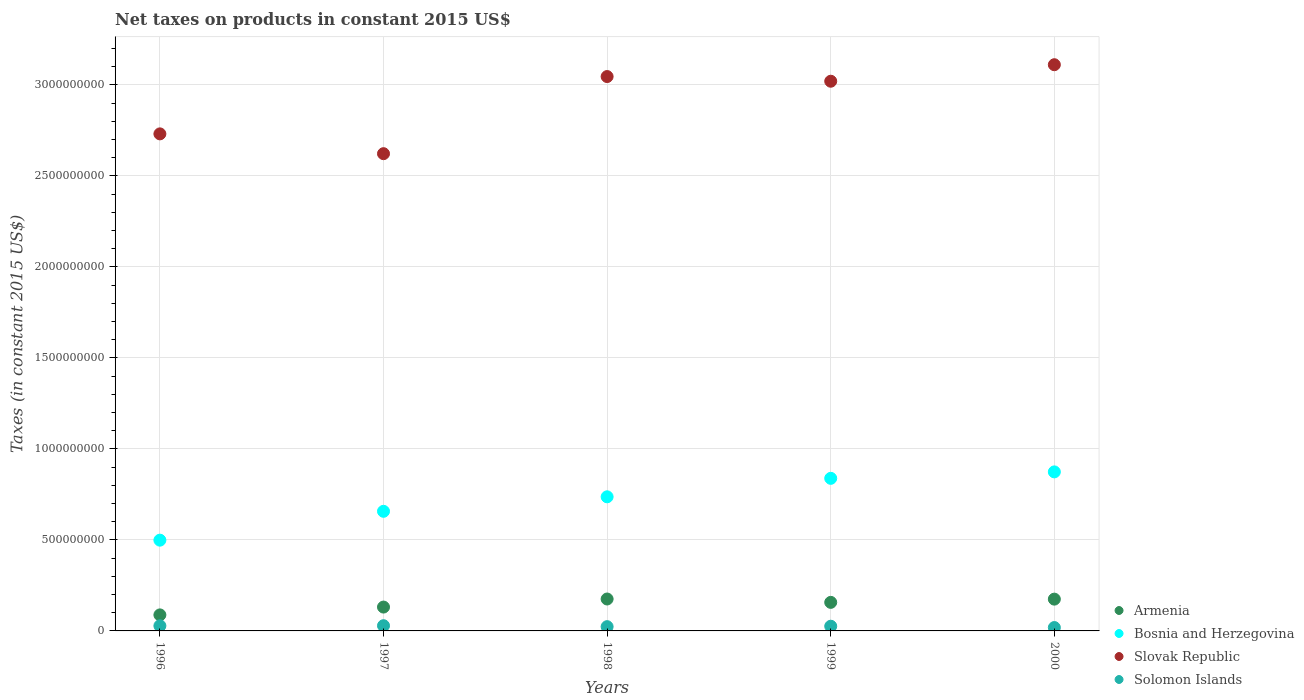How many different coloured dotlines are there?
Offer a very short reply. 4. Is the number of dotlines equal to the number of legend labels?
Provide a short and direct response. Yes. What is the net taxes on products in Slovak Republic in 1997?
Ensure brevity in your answer.  2.62e+09. Across all years, what is the maximum net taxes on products in Bosnia and Herzegovina?
Provide a succinct answer. 8.74e+08. Across all years, what is the minimum net taxes on products in Bosnia and Herzegovina?
Ensure brevity in your answer.  4.99e+08. What is the total net taxes on products in Solomon Islands in the graph?
Offer a very short reply. 1.25e+08. What is the difference between the net taxes on products in Solomon Islands in 1999 and that in 2000?
Your answer should be compact. 7.27e+06. What is the difference between the net taxes on products in Solomon Islands in 1999 and the net taxes on products in Slovak Republic in 1996?
Offer a terse response. -2.71e+09. What is the average net taxes on products in Solomon Islands per year?
Offer a very short reply. 2.49e+07. In the year 2000, what is the difference between the net taxes on products in Bosnia and Herzegovina and net taxes on products in Slovak Republic?
Offer a terse response. -2.24e+09. What is the ratio of the net taxes on products in Slovak Republic in 1997 to that in 1998?
Your answer should be compact. 0.86. Is the net taxes on products in Solomon Islands in 1998 less than that in 1999?
Make the answer very short. Yes. Is the difference between the net taxes on products in Bosnia and Herzegovina in 1997 and 2000 greater than the difference between the net taxes on products in Slovak Republic in 1997 and 2000?
Make the answer very short. Yes. What is the difference between the highest and the second highest net taxes on products in Solomon Islands?
Ensure brevity in your answer.  5.57e+05. What is the difference between the highest and the lowest net taxes on products in Bosnia and Herzegovina?
Offer a terse response. 3.75e+08. Is the sum of the net taxes on products in Solomon Islands in 1996 and 1997 greater than the maximum net taxes on products in Slovak Republic across all years?
Ensure brevity in your answer.  No. Does the net taxes on products in Bosnia and Herzegovina monotonically increase over the years?
Keep it short and to the point. Yes. Is the net taxes on products in Armenia strictly less than the net taxes on products in Solomon Islands over the years?
Your response must be concise. No. How many dotlines are there?
Your response must be concise. 4. How many years are there in the graph?
Your answer should be very brief. 5. What is the difference between two consecutive major ticks on the Y-axis?
Provide a short and direct response. 5.00e+08. Are the values on the major ticks of Y-axis written in scientific E-notation?
Provide a succinct answer. No. Does the graph contain any zero values?
Give a very brief answer. No. What is the title of the graph?
Your answer should be compact. Net taxes on products in constant 2015 US$. What is the label or title of the Y-axis?
Offer a terse response. Taxes (in constant 2015 US$). What is the Taxes (in constant 2015 US$) in Armenia in 1996?
Provide a succinct answer. 8.81e+07. What is the Taxes (in constant 2015 US$) in Bosnia and Herzegovina in 1996?
Offer a terse response. 4.99e+08. What is the Taxes (in constant 2015 US$) of Slovak Republic in 1996?
Give a very brief answer. 2.73e+09. What is the Taxes (in constant 2015 US$) of Solomon Islands in 1996?
Ensure brevity in your answer.  2.81e+07. What is the Taxes (in constant 2015 US$) in Armenia in 1997?
Ensure brevity in your answer.  1.31e+08. What is the Taxes (in constant 2015 US$) in Bosnia and Herzegovina in 1997?
Ensure brevity in your answer.  6.57e+08. What is the Taxes (in constant 2015 US$) of Slovak Republic in 1997?
Your answer should be very brief. 2.62e+09. What is the Taxes (in constant 2015 US$) in Solomon Islands in 1997?
Offer a terse response. 2.87e+07. What is the Taxes (in constant 2015 US$) of Armenia in 1998?
Ensure brevity in your answer.  1.75e+08. What is the Taxes (in constant 2015 US$) in Bosnia and Herzegovina in 1998?
Your answer should be compact. 7.37e+08. What is the Taxes (in constant 2015 US$) in Slovak Republic in 1998?
Give a very brief answer. 3.05e+09. What is the Taxes (in constant 2015 US$) of Solomon Islands in 1998?
Offer a terse response. 2.34e+07. What is the Taxes (in constant 2015 US$) in Armenia in 1999?
Make the answer very short. 1.57e+08. What is the Taxes (in constant 2015 US$) of Bosnia and Herzegovina in 1999?
Give a very brief answer. 8.38e+08. What is the Taxes (in constant 2015 US$) in Slovak Republic in 1999?
Keep it short and to the point. 3.02e+09. What is the Taxes (in constant 2015 US$) in Solomon Islands in 1999?
Give a very brief answer. 2.58e+07. What is the Taxes (in constant 2015 US$) of Armenia in 2000?
Provide a succinct answer. 1.75e+08. What is the Taxes (in constant 2015 US$) in Bosnia and Herzegovina in 2000?
Your answer should be compact. 8.74e+08. What is the Taxes (in constant 2015 US$) of Slovak Republic in 2000?
Offer a very short reply. 3.11e+09. What is the Taxes (in constant 2015 US$) of Solomon Islands in 2000?
Give a very brief answer. 1.86e+07. Across all years, what is the maximum Taxes (in constant 2015 US$) of Armenia?
Ensure brevity in your answer.  1.75e+08. Across all years, what is the maximum Taxes (in constant 2015 US$) in Bosnia and Herzegovina?
Provide a succinct answer. 8.74e+08. Across all years, what is the maximum Taxes (in constant 2015 US$) in Slovak Republic?
Your response must be concise. 3.11e+09. Across all years, what is the maximum Taxes (in constant 2015 US$) of Solomon Islands?
Offer a very short reply. 2.87e+07. Across all years, what is the minimum Taxes (in constant 2015 US$) of Armenia?
Provide a succinct answer. 8.81e+07. Across all years, what is the minimum Taxes (in constant 2015 US$) of Bosnia and Herzegovina?
Make the answer very short. 4.99e+08. Across all years, what is the minimum Taxes (in constant 2015 US$) of Slovak Republic?
Your answer should be compact. 2.62e+09. Across all years, what is the minimum Taxes (in constant 2015 US$) of Solomon Islands?
Keep it short and to the point. 1.86e+07. What is the total Taxes (in constant 2015 US$) of Armenia in the graph?
Your answer should be compact. 7.26e+08. What is the total Taxes (in constant 2015 US$) in Bosnia and Herzegovina in the graph?
Make the answer very short. 3.61e+09. What is the total Taxes (in constant 2015 US$) of Slovak Republic in the graph?
Give a very brief answer. 1.45e+1. What is the total Taxes (in constant 2015 US$) in Solomon Islands in the graph?
Provide a succinct answer. 1.25e+08. What is the difference between the Taxes (in constant 2015 US$) in Armenia in 1996 and that in 1997?
Give a very brief answer. -4.30e+07. What is the difference between the Taxes (in constant 2015 US$) in Bosnia and Herzegovina in 1996 and that in 1997?
Offer a very short reply. -1.59e+08. What is the difference between the Taxes (in constant 2015 US$) of Slovak Republic in 1996 and that in 1997?
Provide a succinct answer. 1.09e+08. What is the difference between the Taxes (in constant 2015 US$) of Solomon Islands in 1996 and that in 1997?
Your response must be concise. -5.57e+05. What is the difference between the Taxes (in constant 2015 US$) of Armenia in 1996 and that in 1998?
Your answer should be compact. -8.73e+07. What is the difference between the Taxes (in constant 2015 US$) of Bosnia and Herzegovina in 1996 and that in 1998?
Ensure brevity in your answer.  -2.38e+08. What is the difference between the Taxes (in constant 2015 US$) in Slovak Republic in 1996 and that in 1998?
Give a very brief answer. -3.15e+08. What is the difference between the Taxes (in constant 2015 US$) in Solomon Islands in 1996 and that in 1998?
Give a very brief answer. 4.67e+06. What is the difference between the Taxes (in constant 2015 US$) of Armenia in 1996 and that in 1999?
Provide a short and direct response. -6.88e+07. What is the difference between the Taxes (in constant 2015 US$) of Bosnia and Herzegovina in 1996 and that in 1999?
Offer a very short reply. -3.40e+08. What is the difference between the Taxes (in constant 2015 US$) in Slovak Republic in 1996 and that in 1999?
Your response must be concise. -2.89e+08. What is the difference between the Taxes (in constant 2015 US$) in Solomon Islands in 1996 and that in 1999?
Offer a terse response. 2.28e+06. What is the difference between the Taxes (in constant 2015 US$) in Armenia in 1996 and that in 2000?
Provide a succinct answer. -8.66e+07. What is the difference between the Taxes (in constant 2015 US$) in Bosnia and Herzegovina in 1996 and that in 2000?
Ensure brevity in your answer.  -3.75e+08. What is the difference between the Taxes (in constant 2015 US$) of Slovak Republic in 1996 and that in 2000?
Your response must be concise. -3.80e+08. What is the difference between the Taxes (in constant 2015 US$) of Solomon Islands in 1996 and that in 2000?
Your response must be concise. 9.55e+06. What is the difference between the Taxes (in constant 2015 US$) in Armenia in 1997 and that in 1998?
Offer a very short reply. -4.43e+07. What is the difference between the Taxes (in constant 2015 US$) of Bosnia and Herzegovina in 1997 and that in 1998?
Offer a terse response. -7.96e+07. What is the difference between the Taxes (in constant 2015 US$) of Slovak Republic in 1997 and that in 1998?
Make the answer very short. -4.24e+08. What is the difference between the Taxes (in constant 2015 US$) in Solomon Islands in 1997 and that in 1998?
Make the answer very short. 5.23e+06. What is the difference between the Taxes (in constant 2015 US$) of Armenia in 1997 and that in 1999?
Provide a succinct answer. -2.58e+07. What is the difference between the Taxes (in constant 2015 US$) in Bosnia and Herzegovina in 1997 and that in 1999?
Offer a very short reply. -1.81e+08. What is the difference between the Taxes (in constant 2015 US$) of Slovak Republic in 1997 and that in 1999?
Your answer should be very brief. -3.98e+08. What is the difference between the Taxes (in constant 2015 US$) of Solomon Islands in 1997 and that in 1999?
Ensure brevity in your answer.  2.84e+06. What is the difference between the Taxes (in constant 2015 US$) of Armenia in 1997 and that in 2000?
Make the answer very short. -4.36e+07. What is the difference between the Taxes (in constant 2015 US$) in Bosnia and Herzegovina in 1997 and that in 2000?
Make the answer very short. -2.17e+08. What is the difference between the Taxes (in constant 2015 US$) of Slovak Republic in 1997 and that in 2000?
Give a very brief answer. -4.89e+08. What is the difference between the Taxes (in constant 2015 US$) of Solomon Islands in 1997 and that in 2000?
Make the answer very short. 1.01e+07. What is the difference between the Taxes (in constant 2015 US$) in Armenia in 1998 and that in 1999?
Your response must be concise. 1.85e+07. What is the difference between the Taxes (in constant 2015 US$) in Bosnia and Herzegovina in 1998 and that in 1999?
Provide a succinct answer. -1.02e+08. What is the difference between the Taxes (in constant 2015 US$) in Slovak Republic in 1998 and that in 1999?
Offer a terse response. 2.57e+07. What is the difference between the Taxes (in constant 2015 US$) of Solomon Islands in 1998 and that in 1999?
Make the answer very short. -2.39e+06. What is the difference between the Taxes (in constant 2015 US$) in Armenia in 1998 and that in 2000?
Your answer should be compact. 7.20e+05. What is the difference between the Taxes (in constant 2015 US$) of Bosnia and Herzegovina in 1998 and that in 2000?
Offer a terse response. -1.37e+08. What is the difference between the Taxes (in constant 2015 US$) in Slovak Republic in 1998 and that in 2000?
Offer a terse response. -6.50e+07. What is the difference between the Taxes (in constant 2015 US$) in Solomon Islands in 1998 and that in 2000?
Your answer should be compact. 4.87e+06. What is the difference between the Taxes (in constant 2015 US$) in Armenia in 1999 and that in 2000?
Your response must be concise. -1.78e+07. What is the difference between the Taxes (in constant 2015 US$) in Bosnia and Herzegovina in 1999 and that in 2000?
Keep it short and to the point. -3.54e+07. What is the difference between the Taxes (in constant 2015 US$) in Slovak Republic in 1999 and that in 2000?
Offer a terse response. -9.08e+07. What is the difference between the Taxes (in constant 2015 US$) of Solomon Islands in 1999 and that in 2000?
Ensure brevity in your answer.  7.27e+06. What is the difference between the Taxes (in constant 2015 US$) in Armenia in 1996 and the Taxes (in constant 2015 US$) in Bosnia and Herzegovina in 1997?
Keep it short and to the point. -5.69e+08. What is the difference between the Taxes (in constant 2015 US$) in Armenia in 1996 and the Taxes (in constant 2015 US$) in Slovak Republic in 1997?
Ensure brevity in your answer.  -2.53e+09. What is the difference between the Taxes (in constant 2015 US$) of Armenia in 1996 and the Taxes (in constant 2015 US$) of Solomon Islands in 1997?
Offer a very short reply. 5.94e+07. What is the difference between the Taxes (in constant 2015 US$) in Bosnia and Herzegovina in 1996 and the Taxes (in constant 2015 US$) in Slovak Republic in 1997?
Offer a terse response. -2.12e+09. What is the difference between the Taxes (in constant 2015 US$) of Bosnia and Herzegovina in 1996 and the Taxes (in constant 2015 US$) of Solomon Islands in 1997?
Make the answer very short. 4.70e+08. What is the difference between the Taxes (in constant 2015 US$) of Slovak Republic in 1996 and the Taxes (in constant 2015 US$) of Solomon Islands in 1997?
Your answer should be very brief. 2.70e+09. What is the difference between the Taxes (in constant 2015 US$) of Armenia in 1996 and the Taxes (in constant 2015 US$) of Bosnia and Herzegovina in 1998?
Keep it short and to the point. -6.49e+08. What is the difference between the Taxes (in constant 2015 US$) of Armenia in 1996 and the Taxes (in constant 2015 US$) of Slovak Republic in 1998?
Your answer should be very brief. -2.96e+09. What is the difference between the Taxes (in constant 2015 US$) in Armenia in 1996 and the Taxes (in constant 2015 US$) in Solomon Islands in 1998?
Give a very brief answer. 6.46e+07. What is the difference between the Taxes (in constant 2015 US$) in Bosnia and Herzegovina in 1996 and the Taxes (in constant 2015 US$) in Slovak Republic in 1998?
Ensure brevity in your answer.  -2.55e+09. What is the difference between the Taxes (in constant 2015 US$) in Bosnia and Herzegovina in 1996 and the Taxes (in constant 2015 US$) in Solomon Islands in 1998?
Give a very brief answer. 4.75e+08. What is the difference between the Taxes (in constant 2015 US$) in Slovak Republic in 1996 and the Taxes (in constant 2015 US$) in Solomon Islands in 1998?
Offer a terse response. 2.71e+09. What is the difference between the Taxes (in constant 2015 US$) in Armenia in 1996 and the Taxes (in constant 2015 US$) in Bosnia and Herzegovina in 1999?
Offer a terse response. -7.50e+08. What is the difference between the Taxes (in constant 2015 US$) in Armenia in 1996 and the Taxes (in constant 2015 US$) in Slovak Republic in 1999?
Make the answer very short. -2.93e+09. What is the difference between the Taxes (in constant 2015 US$) in Armenia in 1996 and the Taxes (in constant 2015 US$) in Solomon Islands in 1999?
Give a very brief answer. 6.23e+07. What is the difference between the Taxes (in constant 2015 US$) in Bosnia and Herzegovina in 1996 and the Taxes (in constant 2015 US$) in Slovak Republic in 1999?
Make the answer very short. -2.52e+09. What is the difference between the Taxes (in constant 2015 US$) of Bosnia and Herzegovina in 1996 and the Taxes (in constant 2015 US$) of Solomon Islands in 1999?
Provide a short and direct response. 4.73e+08. What is the difference between the Taxes (in constant 2015 US$) of Slovak Republic in 1996 and the Taxes (in constant 2015 US$) of Solomon Islands in 1999?
Your answer should be very brief. 2.71e+09. What is the difference between the Taxes (in constant 2015 US$) of Armenia in 1996 and the Taxes (in constant 2015 US$) of Bosnia and Herzegovina in 2000?
Offer a terse response. -7.86e+08. What is the difference between the Taxes (in constant 2015 US$) in Armenia in 1996 and the Taxes (in constant 2015 US$) in Slovak Republic in 2000?
Your answer should be compact. -3.02e+09. What is the difference between the Taxes (in constant 2015 US$) in Armenia in 1996 and the Taxes (in constant 2015 US$) in Solomon Islands in 2000?
Provide a short and direct response. 6.95e+07. What is the difference between the Taxes (in constant 2015 US$) in Bosnia and Herzegovina in 1996 and the Taxes (in constant 2015 US$) in Slovak Republic in 2000?
Your answer should be compact. -2.61e+09. What is the difference between the Taxes (in constant 2015 US$) of Bosnia and Herzegovina in 1996 and the Taxes (in constant 2015 US$) of Solomon Islands in 2000?
Your response must be concise. 4.80e+08. What is the difference between the Taxes (in constant 2015 US$) of Slovak Republic in 1996 and the Taxes (in constant 2015 US$) of Solomon Islands in 2000?
Ensure brevity in your answer.  2.71e+09. What is the difference between the Taxes (in constant 2015 US$) of Armenia in 1997 and the Taxes (in constant 2015 US$) of Bosnia and Herzegovina in 1998?
Provide a succinct answer. -6.06e+08. What is the difference between the Taxes (in constant 2015 US$) of Armenia in 1997 and the Taxes (in constant 2015 US$) of Slovak Republic in 1998?
Your answer should be compact. -2.91e+09. What is the difference between the Taxes (in constant 2015 US$) in Armenia in 1997 and the Taxes (in constant 2015 US$) in Solomon Islands in 1998?
Your response must be concise. 1.08e+08. What is the difference between the Taxes (in constant 2015 US$) in Bosnia and Herzegovina in 1997 and the Taxes (in constant 2015 US$) in Slovak Republic in 1998?
Your response must be concise. -2.39e+09. What is the difference between the Taxes (in constant 2015 US$) of Bosnia and Herzegovina in 1997 and the Taxes (in constant 2015 US$) of Solomon Islands in 1998?
Your response must be concise. 6.34e+08. What is the difference between the Taxes (in constant 2015 US$) of Slovak Republic in 1997 and the Taxes (in constant 2015 US$) of Solomon Islands in 1998?
Ensure brevity in your answer.  2.60e+09. What is the difference between the Taxes (in constant 2015 US$) in Armenia in 1997 and the Taxes (in constant 2015 US$) in Bosnia and Herzegovina in 1999?
Make the answer very short. -7.07e+08. What is the difference between the Taxes (in constant 2015 US$) in Armenia in 1997 and the Taxes (in constant 2015 US$) in Slovak Republic in 1999?
Provide a succinct answer. -2.89e+09. What is the difference between the Taxes (in constant 2015 US$) of Armenia in 1997 and the Taxes (in constant 2015 US$) of Solomon Islands in 1999?
Provide a succinct answer. 1.05e+08. What is the difference between the Taxes (in constant 2015 US$) of Bosnia and Herzegovina in 1997 and the Taxes (in constant 2015 US$) of Slovak Republic in 1999?
Give a very brief answer. -2.36e+09. What is the difference between the Taxes (in constant 2015 US$) in Bosnia and Herzegovina in 1997 and the Taxes (in constant 2015 US$) in Solomon Islands in 1999?
Offer a terse response. 6.31e+08. What is the difference between the Taxes (in constant 2015 US$) in Slovak Republic in 1997 and the Taxes (in constant 2015 US$) in Solomon Islands in 1999?
Provide a succinct answer. 2.60e+09. What is the difference between the Taxes (in constant 2015 US$) of Armenia in 1997 and the Taxes (in constant 2015 US$) of Bosnia and Herzegovina in 2000?
Your answer should be compact. -7.43e+08. What is the difference between the Taxes (in constant 2015 US$) in Armenia in 1997 and the Taxes (in constant 2015 US$) in Slovak Republic in 2000?
Your answer should be very brief. -2.98e+09. What is the difference between the Taxes (in constant 2015 US$) in Armenia in 1997 and the Taxes (in constant 2015 US$) in Solomon Islands in 2000?
Offer a terse response. 1.13e+08. What is the difference between the Taxes (in constant 2015 US$) in Bosnia and Herzegovina in 1997 and the Taxes (in constant 2015 US$) in Slovak Republic in 2000?
Your answer should be compact. -2.45e+09. What is the difference between the Taxes (in constant 2015 US$) of Bosnia and Herzegovina in 1997 and the Taxes (in constant 2015 US$) of Solomon Islands in 2000?
Your answer should be very brief. 6.39e+08. What is the difference between the Taxes (in constant 2015 US$) of Slovak Republic in 1997 and the Taxes (in constant 2015 US$) of Solomon Islands in 2000?
Provide a succinct answer. 2.60e+09. What is the difference between the Taxes (in constant 2015 US$) of Armenia in 1998 and the Taxes (in constant 2015 US$) of Bosnia and Herzegovina in 1999?
Your response must be concise. -6.63e+08. What is the difference between the Taxes (in constant 2015 US$) in Armenia in 1998 and the Taxes (in constant 2015 US$) in Slovak Republic in 1999?
Provide a short and direct response. -2.84e+09. What is the difference between the Taxes (in constant 2015 US$) of Armenia in 1998 and the Taxes (in constant 2015 US$) of Solomon Islands in 1999?
Your response must be concise. 1.50e+08. What is the difference between the Taxes (in constant 2015 US$) in Bosnia and Herzegovina in 1998 and the Taxes (in constant 2015 US$) in Slovak Republic in 1999?
Your answer should be compact. -2.28e+09. What is the difference between the Taxes (in constant 2015 US$) of Bosnia and Herzegovina in 1998 and the Taxes (in constant 2015 US$) of Solomon Islands in 1999?
Keep it short and to the point. 7.11e+08. What is the difference between the Taxes (in constant 2015 US$) in Slovak Republic in 1998 and the Taxes (in constant 2015 US$) in Solomon Islands in 1999?
Your answer should be compact. 3.02e+09. What is the difference between the Taxes (in constant 2015 US$) of Armenia in 1998 and the Taxes (in constant 2015 US$) of Bosnia and Herzegovina in 2000?
Give a very brief answer. -6.98e+08. What is the difference between the Taxes (in constant 2015 US$) in Armenia in 1998 and the Taxes (in constant 2015 US$) in Slovak Republic in 2000?
Offer a terse response. -2.94e+09. What is the difference between the Taxes (in constant 2015 US$) in Armenia in 1998 and the Taxes (in constant 2015 US$) in Solomon Islands in 2000?
Your answer should be compact. 1.57e+08. What is the difference between the Taxes (in constant 2015 US$) in Bosnia and Herzegovina in 1998 and the Taxes (in constant 2015 US$) in Slovak Republic in 2000?
Make the answer very short. -2.37e+09. What is the difference between the Taxes (in constant 2015 US$) in Bosnia and Herzegovina in 1998 and the Taxes (in constant 2015 US$) in Solomon Islands in 2000?
Your response must be concise. 7.18e+08. What is the difference between the Taxes (in constant 2015 US$) in Slovak Republic in 1998 and the Taxes (in constant 2015 US$) in Solomon Islands in 2000?
Provide a succinct answer. 3.03e+09. What is the difference between the Taxes (in constant 2015 US$) of Armenia in 1999 and the Taxes (in constant 2015 US$) of Bosnia and Herzegovina in 2000?
Provide a succinct answer. -7.17e+08. What is the difference between the Taxes (in constant 2015 US$) in Armenia in 1999 and the Taxes (in constant 2015 US$) in Slovak Republic in 2000?
Your answer should be compact. -2.95e+09. What is the difference between the Taxes (in constant 2015 US$) in Armenia in 1999 and the Taxes (in constant 2015 US$) in Solomon Islands in 2000?
Your answer should be very brief. 1.38e+08. What is the difference between the Taxes (in constant 2015 US$) of Bosnia and Herzegovina in 1999 and the Taxes (in constant 2015 US$) of Slovak Republic in 2000?
Your answer should be compact. -2.27e+09. What is the difference between the Taxes (in constant 2015 US$) of Bosnia and Herzegovina in 1999 and the Taxes (in constant 2015 US$) of Solomon Islands in 2000?
Offer a terse response. 8.20e+08. What is the difference between the Taxes (in constant 2015 US$) in Slovak Republic in 1999 and the Taxes (in constant 2015 US$) in Solomon Islands in 2000?
Offer a very short reply. 3.00e+09. What is the average Taxes (in constant 2015 US$) in Armenia per year?
Ensure brevity in your answer.  1.45e+08. What is the average Taxes (in constant 2015 US$) of Bosnia and Herzegovina per year?
Your response must be concise. 7.21e+08. What is the average Taxes (in constant 2015 US$) in Slovak Republic per year?
Keep it short and to the point. 2.91e+09. What is the average Taxes (in constant 2015 US$) of Solomon Islands per year?
Make the answer very short. 2.49e+07. In the year 1996, what is the difference between the Taxes (in constant 2015 US$) in Armenia and Taxes (in constant 2015 US$) in Bosnia and Herzegovina?
Provide a succinct answer. -4.11e+08. In the year 1996, what is the difference between the Taxes (in constant 2015 US$) of Armenia and Taxes (in constant 2015 US$) of Slovak Republic?
Your answer should be very brief. -2.64e+09. In the year 1996, what is the difference between the Taxes (in constant 2015 US$) of Armenia and Taxes (in constant 2015 US$) of Solomon Islands?
Offer a terse response. 6.00e+07. In the year 1996, what is the difference between the Taxes (in constant 2015 US$) of Bosnia and Herzegovina and Taxes (in constant 2015 US$) of Slovak Republic?
Offer a terse response. -2.23e+09. In the year 1996, what is the difference between the Taxes (in constant 2015 US$) in Bosnia and Herzegovina and Taxes (in constant 2015 US$) in Solomon Islands?
Ensure brevity in your answer.  4.71e+08. In the year 1996, what is the difference between the Taxes (in constant 2015 US$) of Slovak Republic and Taxes (in constant 2015 US$) of Solomon Islands?
Offer a terse response. 2.70e+09. In the year 1997, what is the difference between the Taxes (in constant 2015 US$) of Armenia and Taxes (in constant 2015 US$) of Bosnia and Herzegovina?
Give a very brief answer. -5.26e+08. In the year 1997, what is the difference between the Taxes (in constant 2015 US$) in Armenia and Taxes (in constant 2015 US$) in Slovak Republic?
Your answer should be compact. -2.49e+09. In the year 1997, what is the difference between the Taxes (in constant 2015 US$) in Armenia and Taxes (in constant 2015 US$) in Solomon Islands?
Give a very brief answer. 1.02e+08. In the year 1997, what is the difference between the Taxes (in constant 2015 US$) in Bosnia and Herzegovina and Taxes (in constant 2015 US$) in Slovak Republic?
Your answer should be very brief. -1.97e+09. In the year 1997, what is the difference between the Taxes (in constant 2015 US$) in Bosnia and Herzegovina and Taxes (in constant 2015 US$) in Solomon Islands?
Your answer should be compact. 6.29e+08. In the year 1997, what is the difference between the Taxes (in constant 2015 US$) of Slovak Republic and Taxes (in constant 2015 US$) of Solomon Islands?
Your answer should be very brief. 2.59e+09. In the year 1998, what is the difference between the Taxes (in constant 2015 US$) in Armenia and Taxes (in constant 2015 US$) in Bosnia and Herzegovina?
Your answer should be compact. -5.62e+08. In the year 1998, what is the difference between the Taxes (in constant 2015 US$) in Armenia and Taxes (in constant 2015 US$) in Slovak Republic?
Ensure brevity in your answer.  -2.87e+09. In the year 1998, what is the difference between the Taxes (in constant 2015 US$) in Armenia and Taxes (in constant 2015 US$) in Solomon Islands?
Your answer should be compact. 1.52e+08. In the year 1998, what is the difference between the Taxes (in constant 2015 US$) in Bosnia and Herzegovina and Taxes (in constant 2015 US$) in Slovak Republic?
Provide a short and direct response. -2.31e+09. In the year 1998, what is the difference between the Taxes (in constant 2015 US$) of Bosnia and Herzegovina and Taxes (in constant 2015 US$) of Solomon Islands?
Keep it short and to the point. 7.13e+08. In the year 1998, what is the difference between the Taxes (in constant 2015 US$) in Slovak Republic and Taxes (in constant 2015 US$) in Solomon Islands?
Make the answer very short. 3.02e+09. In the year 1999, what is the difference between the Taxes (in constant 2015 US$) in Armenia and Taxes (in constant 2015 US$) in Bosnia and Herzegovina?
Keep it short and to the point. -6.82e+08. In the year 1999, what is the difference between the Taxes (in constant 2015 US$) of Armenia and Taxes (in constant 2015 US$) of Slovak Republic?
Provide a short and direct response. -2.86e+09. In the year 1999, what is the difference between the Taxes (in constant 2015 US$) in Armenia and Taxes (in constant 2015 US$) in Solomon Islands?
Give a very brief answer. 1.31e+08. In the year 1999, what is the difference between the Taxes (in constant 2015 US$) of Bosnia and Herzegovina and Taxes (in constant 2015 US$) of Slovak Republic?
Give a very brief answer. -2.18e+09. In the year 1999, what is the difference between the Taxes (in constant 2015 US$) in Bosnia and Herzegovina and Taxes (in constant 2015 US$) in Solomon Islands?
Offer a terse response. 8.13e+08. In the year 1999, what is the difference between the Taxes (in constant 2015 US$) of Slovak Republic and Taxes (in constant 2015 US$) of Solomon Islands?
Offer a terse response. 2.99e+09. In the year 2000, what is the difference between the Taxes (in constant 2015 US$) of Armenia and Taxes (in constant 2015 US$) of Bosnia and Herzegovina?
Make the answer very short. -6.99e+08. In the year 2000, what is the difference between the Taxes (in constant 2015 US$) of Armenia and Taxes (in constant 2015 US$) of Slovak Republic?
Your response must be concise. -2.94e+09. In the year 2000, what is the difference between the Taxes (in constant 2015 US$) of Armenia and Taxes (in constant 2015 US$) of Solomon Islands?
Ensure brevity in your answer.  1.56e+08. In the year 2000, what is the difference between the Taxes (in constant 2015 US$) in Bosnia and Herzegovina and Taxes (in constant 2015 US$) in Slovak Republic?
Ensure brevity in your answer.  -2.24e+09. In the year 2000, what is the difference between the Taxes (in constant 2015 US$) of Bosnia and Herzegovina and Taxes (in constant 2015 US$) of Solomon Islands?
Make the answer very short. 8.55e+08. In the year 2000, what is the difference between the Taxes (in constant 2015 US$) of Slovak Republic and Taxes (in constant 2015 US$) of Solomon Islands?
Give a very brief answer. 3.09e+09. What is the ratio of the Taxes (in constant 2015 US$) of Armenia in 1996 to that in 1997?
Provide a short and direct response. 0.67. What is the ratio of the Taxes (in constant 2015 US$) in Bosnia and Herzegovina in 1996 to that in 1997?
Your answer should be compact. 0.76. What is the ratio of the Taxes (in constant 2015 US$) of Slovak Republic in 1996 to that in 1997?
Your answer should be compact. 1.04. What is the ratio of the Taxes (in constant 2015 US$) in Solomon Islands in 1996 to that in 1997?
Offer a terse response. 0.98. What is the ratio of the Taxes (in constant 2015 US$) in Armenia in 1996 to that in 1998?
Your response must be concise. 0.5. What is the ratio of the Taxes (in constant 2015 US$) in Bosnia and Herzegovina in 1996 to that in 1998?
Offer a very short reply. 0.68. What is the ratio of the Taxes (in constant 2015 US$) in Slovak Republic in 1996 to that in 1998?
Give a very brief answer. 0.9. What is the ratio of the Taxes (in constant 2015 US$) of Solomon Islands in 1996 to that in 1998?
Your answer should be very brief. 1.2. What is the ratio of the Taxes (in constant 2015 US$) in Armenia in 1996 to that in 1999?
Your answer should be very brief. 0.56. What is the ratio of the Taxes (in constant 2015 US$) in Bosnia and Herzegovina in 1996 to that in 1999?
Give a very brief answer. 0.59. What is the ratio of the Taxes (in constant 2015 US$) of Slovak Republic in 1996 to that in 1999?
Provide a short and direct response. 0.9. What is the ratio of the Taxes (in constant 2015 US$) in Solomon Islands in 1996 to that in 1999?
Give a very brief answer. 1.09. What is the ratio of the Taxes (in constant 2015 US$) of Armenia in 1996 to that in 2000?
Keep it short and to the point. 0.5. What is the ratio of the Taxes (in constant 2015 US$) of Bosnia and Herzegovina in 1996 to that in 2000?
Ensure brevity in your answer.  0.57. What is the ratio of the Taxes (in constant 2015 US$) of Slovak Republic in 1996 to that in 2000?
Your answer should be compact. 0.88. What is the ratio of the Taxes (in constant 2015 US$) in Solomon Islands in 1996 to that in 2000?
Offer a terse response. 1.51. What is the ratio of the Taxes (in constant 2015 US$) in Armenia in 1997 to that in 1998?
Provide a succinct answer. 0.75. What is the ratio of the Taxes (in constant 2015 US$) of Bosnia and Herzegovina in 1997 to that in 1998?
Keep it short and to the point. 0.89. What is the ratio of the Taxes (in constant 2015 US$) in Slovak Republic in 1997 to that in 1998?
Your response must be concise. 0.86. What is the ratio of the Taxes (in constant 2015 US$) in Solomon Islands in 1997 to that in 1998?
Provide a succinct answer. 1.22. What is the ratio of the Taxes (in constant 2015 US$) in Armenia in 1997 to that in 1999?
Provide a succinct answer. 0.84. What is the ratio of the Taxes (in constant 2015 US$) in Bosnia and Herzegovina in 1997 to that in 1999?
Ensure brevity in your answer.  0.78. What is the ratio of the Taxes (in constant 2015 US$) in Slovak Republic in 1997 to that in 1999?
Ensure brevity in your answer.  0.87. What is the ratio of the Taxes (in constant 2015 US$) in Solomon Islands in 1997 to that in 1999?
Provide a succinct answer. 1.11. What is the ratio of the Taxes (in constant 2015 US$) of Armenia in 1997 to that in 2000?
Your response must be concise. 0.75. What is the ratio of the Taxes (in constant 2015 US$) of Bosnia and Herzegovina in 1997 to that in 2000?
Provide a succinct answer. 0.75. What is the ratio of the Taxes (in constant 2015 US$) of Slovak Republic in 1997 to that in 2000?
Offer a terse response. 0.84. What is the ratio of the Taxes (in constant 2015 US$) of Solomon Islands in 1997 to that in 2000?
Give a very brief answer. 1.54. What is the ratio of the Taxes (in constant 2015 US$) of Armenia in 1998 to that in 1999?
Ensure brevity in your answer.  1.12. What is the ratio of the Taxes (in constant 2015 US$) of Bosnia and Herzegovina in 1998 to that in 1999?
Provide a short and direct response. 0.88. What is the ratio of the Taxes (in constant 2015 US$) in Slovak Republic in 1998 to that in 1999?
Make the answer very short. 1.01. What is the ratio of the Taxes (in constant 2015 US$) in Solomon Islands in 1998 to that in 1999?
Ensure brevity in your answer.  0.91. What is the ratio of the Taxes (in constant 2015 US$) of Armenia in 1998 to that in 2000?
Make the answer very short. 1. What is the ratio of the Taxes (in constant 2015 US$) of Bosnia and Herzegovina in 1998 to that in 2000?
Provide a short and direct response. 0.84. What is the ratio of the Taxes (in constant 2015 US$) in Slovak Republic in 1998 to that in 2000?
Provide a succinct answer. 0.98. What is the ratio of the Taxes (in constant 2015 US$) in Solomon Islands in 1998 to that in 2000?
Your response must be concise. 1.26. What is the ratio of the Taxes (in constant 2015 US$) in Armenia in 1999 to that in 2000?
Keep it short and to the point. 0.9. What is the ratio of the Taxes (in constant 2015 US$) of Bosnia and Herzegovina in 1999 to that in 2000?
Provide a short and direct response. 0.96. What is the ratio of the Taxes (in constant 2015 US$) in Slovak Republic in 1999 to that in 2000?
Your answer should be compact. 0.97. What is the ratio of the Taxes (in constant 2015 US$) of Solomon Islands in 1999 to that in 2000?
Offer a very short reply. 1.39. What is the difference between the highest and the second highest Taxes (in constant 2015 US$) of Armenia?
Provide a short and direct response. 7.20e+05. What is the difference between the highest and the second highest Taxes (in constant 2015 US$) of Bosnia and Herzegovina?
Give a very brief answer. 3.54e+07. What is the difference between the highest and the second highest Taxes (in constant 2015 US$) of Slovak Republic?
Give a very brief answer. 6.50e+07. What is the difference between the highest and the second highest Taxes (in constant 2015 US$) in Solomon Islands?
Your answer should be compact. 5.57e+05. What is the difference between the highest and the lowest Taxes (in constant 2015 US$) in Armenia?
Your answer should be compact. 8.73e+07. What is the difference between the highest and the lowest Taxes (in constant 2015 US$) of Bosnia and Herzegovina?
Give a very brief answer. 3.75e+08. What is the difference between the highest and the lowest Taxes (in constant 2015 US$) in Slovak Republic?
Your answer should be compact. 4.89e+08. What is the difference between the highest and the lowest Taxes (in constant 2015 US$) of Solomon Islands?
Make the answer very short. 1.01e+07. 